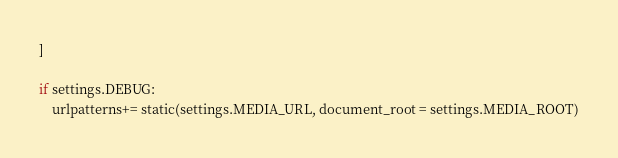<code> <loc_0><loc_0><loc_500><loc_500><_Python_>]

if settings.DEBUG:
    urlpatterns+= static(settings.MEDIA_URL, document_root = settings.MEDIA_ROOT)
</code> 